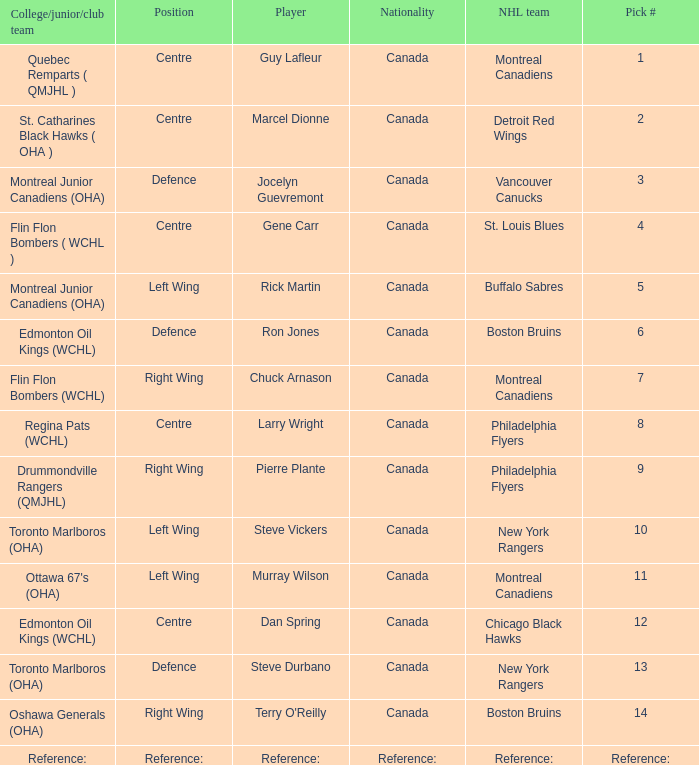Which Pick # has an NHL team of detroit red wings? 2.0. 